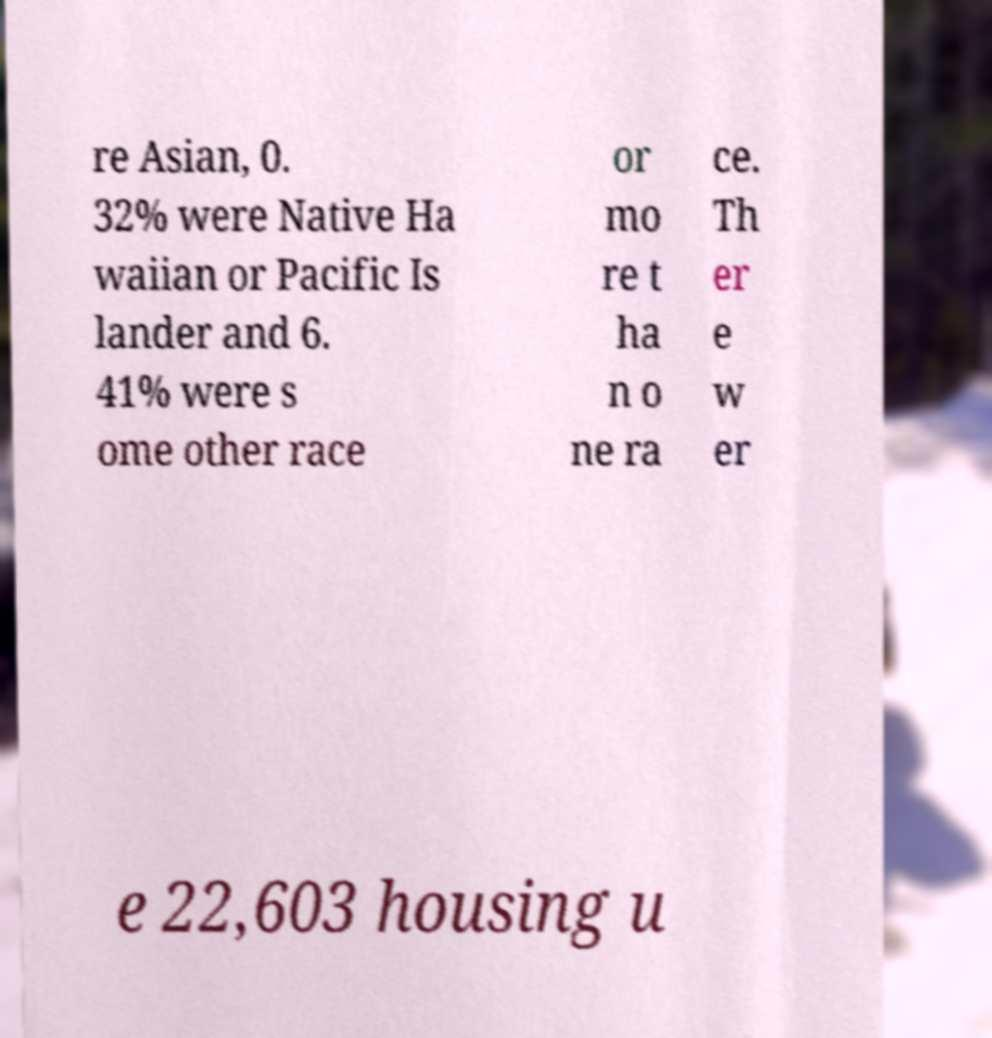I need the written content from this picture converted into text. Can you do that? re Asian, 0. 32% were Native Ha waiian or Pacific Is lander and 6. 41% were s ome other race or mo re t ha n o ne ra ce. Th er e w er e 22,603 housing u 